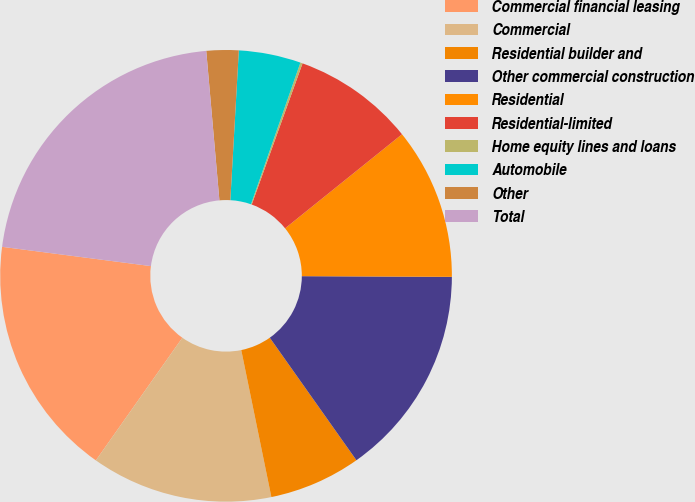Convert chart to OTSL. <chart><loc_0><loc_0><loc_500><loc_500><pie_chart><fcel>Commercial financial leasing<fcel>Commercial<fcel>Residential builder and<fcel>Other commercial construction<fcel>Residential<fcel>Residential-limited<fcel>Home equity lines and loans<fcel>Automobile<fcel>Other<fcel>Total<nl><fcel>17.28%<fcel>13.0%<fcel>6.58%<fcel>15.14%<fcel>10.86%<fcel>8.72%<fcel>0.16%<fcel>4.44%<fcel>2.3%<fcel>21.56%<nl></chart> 